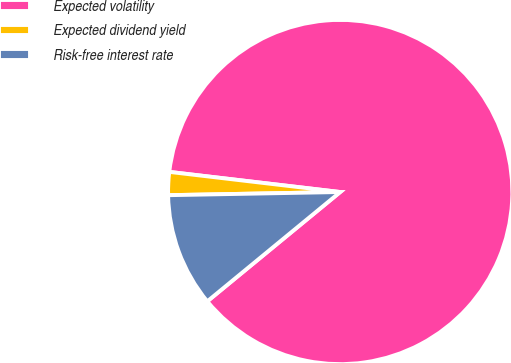Convert chart. <chart><loc_0><loc_0><loc_500><loc_500><pie_chart><fcel>Expected volatility<fcel>Expected dividend yield<fcel>Risk-free interest rate<nl><fcel>87.18%<fcel>2.16%<fcel>10.66%<nl></chart> 